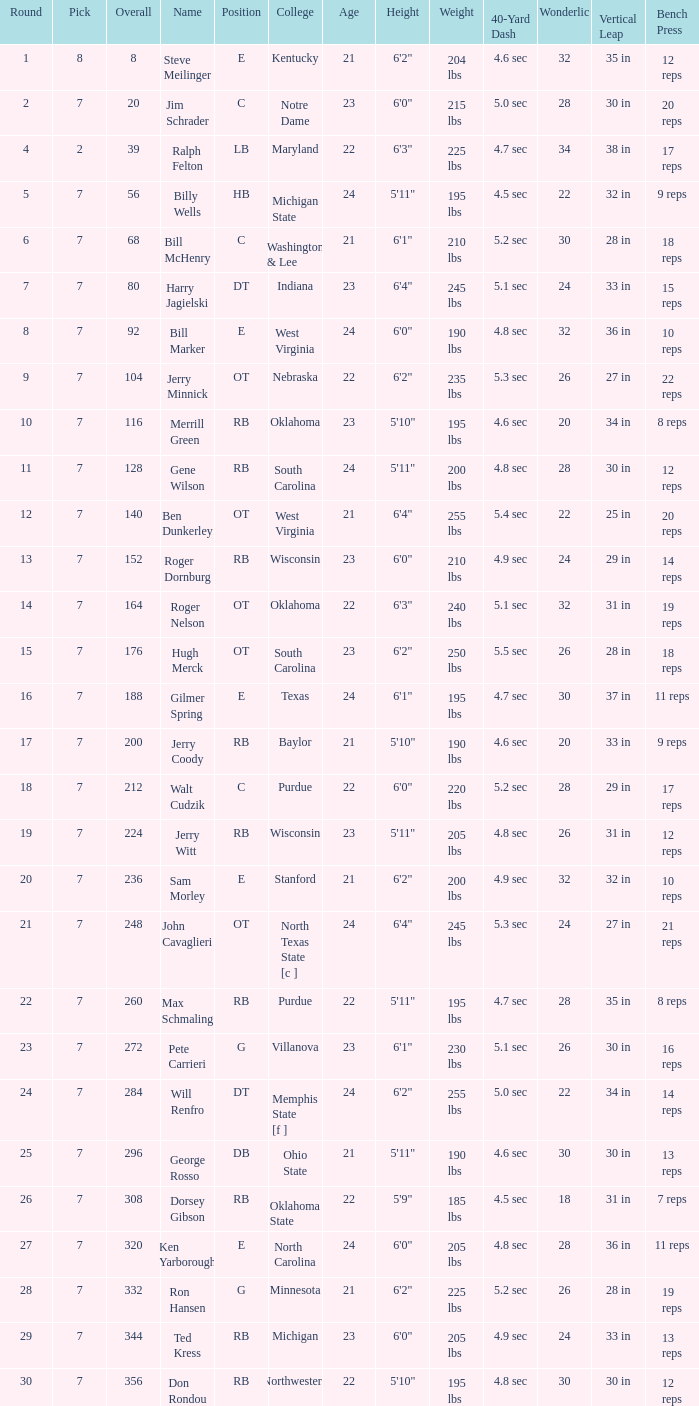What is the number of the round in which Ron Hansen was drafted and the overall is greater than 332? 0.0. 